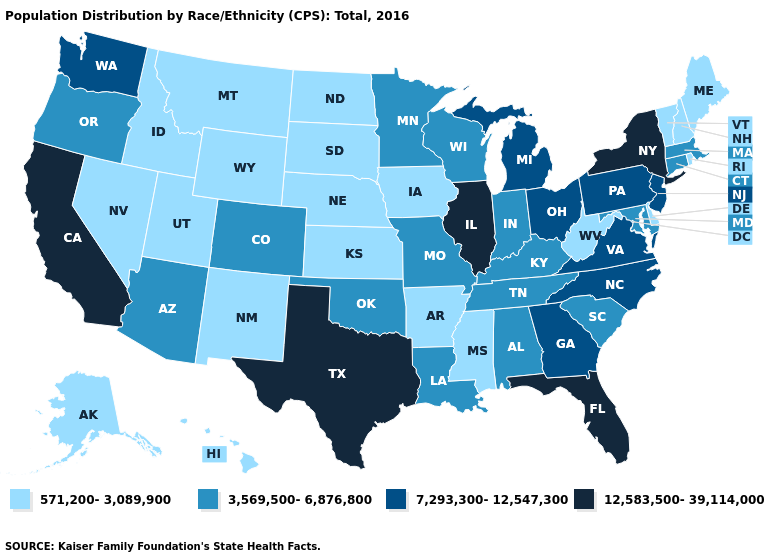What is the value of Wyoming?
Short answer required. 571,200-3,089,900. What is the value of Louisiana?
Write a very short answer. 3,569,500-6,876,800. What is the value of Georgia?
Keep it brief. 7,293,300-12,547,300. What is the highest value in the MidWest ?
Answer briefly. 12,583,500-39,114,000. Name the states that have a value in the range 12,583,500-39,114,000?
Write a very short answer. California, Florida, Illinois, New York, Texas. Among the states that border Minnesota , which have the lowest value?
Give a very brief answer. Iowa, North Dakota, South Dakota. What is the value of North Carolina?
Concise answer only. 7,293,300-12,547,300. What is the value of Oregon?
Concise answer only. 3,569,500-6,876,800. What is the highest value in states that border Rhode Island?
Short answer required. 3,569,500-6,876,800. Which states have the highest value in the USA?
Quick response, please. California, Florida, Illinois, New York, Texas. Name the states that have a value in the range 571,200-3,089,900?
Concise answer only. Alaska, Arkansas, Delaware, Hawaii, Idaho, Iowa, Kansas, Maine, Mississippi, Montana, Nebraska, Nevada, New Hampshire, New Mexico, North Dakota, Rhode Island, South Dakota, Utah, Vermont, West Virginia, Wyoming. Among the states that border Virginia , does Tennessee have the highest value?
Concise answer only. No. What is the highest value in states that border Kansas?
Answer briefly. 3,569,500-6,876,800. Which states have the highest value in the USA?
Quick response, please. California, Florida, Illinois, New York, Texas. Name the states that have a value in the range 12,583,500-39,114,000?
Keep it brief. California, Florida, Illinois, New York, Texas. 